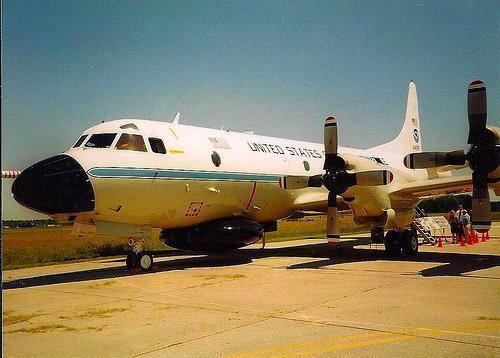How many cones are there?
Give a very brief answer. 6. 